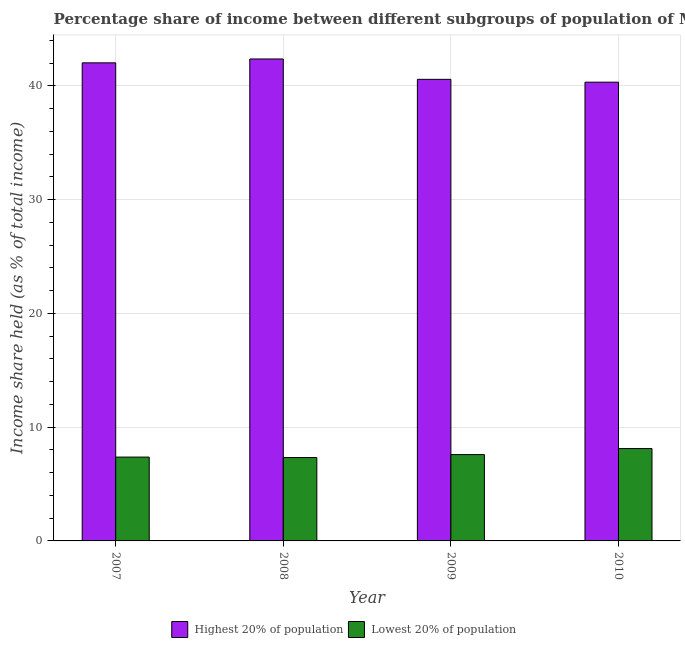How many bars are there on the 4th tick from the right?
Make the answer very short. 2. What is the label of the 2nd group of bars from the left?
Your answer should be compact. 2008. What is the income share held by lowest 20% of the population in 2009?
Keep it short and to the point. 7.59. Across all years, what is the maximum income share held by highest 20% of the population?
Offer a terse response. 42.37. Across all years, what is the minimum income share held by highest 20% of the population?
Your response must be concise. 40.33. In which year was the income share held by highest 20% of the population maximum?
Provide a short and direct response. 2008. What is the total income share held by lowest 20% of the population in the graph?
Offer a very short reply. 30.41. What is the difference between the income share held by lowest 20% of the population in 2007 and that in 2008?
Provide a short and direct response. 0.04. What is the difference between the income share held by lowest 20% of the population in 2009 and the income share held by highest 20% of the population in 2010?
Keep it short and to the point. -0.53. What is the average income share held by highest 20% of the population per year?
Your response must be concise. 41.33. In how many years, is the income share held by highest 20% of the population greater than 16 %?
Your answer should be compact. 4. What is the ratio of the income share held by highest 20% of the population in 2008 to that in 2009?
Ensure brevity in your answer.  1.04. Is the income share held by lowest 20% of the population in 2008 less than that in 2010?
Make the answer very short. Yes. Is the difference between the income share held by lowest 20% of the population in 2008 and 2010 greater than the difference between the income share held by highest 20% of the population in 2008 and 2010?
Ensure brevity in your answer.  No. What is the difference between the highest and the second highest income share held by highest 20% of the population?
Your answer should be very brief. 0.34. What is the difference between the highest and the lowest income share held by lowest 20% of the population?
Ensure brevity in your answer.  0.79. What does the 1st bar from the left in 2010 represents?
Make the answer very short. Highest 20% of population. What does the 1st bar from the right in 2009 represents?
Provide a short and direct response. Lowest 20% of population. How many bars are there?
Ensure brevity in your answer.  8. Are all the bars in the graph horizontal?
Provide a short and direct response. No. How many years are there in the graph?
Ensure brevity in your answer.  4. What is the difference between two consecutive major ticks on the Y-axis?
Give a very brief answer. 10. Are the values on the major ticks of Y-axis written in scientific E-notation?
Make the answer very short. No. Does the graph contain any zero values?
Provide a short and direct response. No. Does the graph contain grids?
Make the answer very short. Yes. Where does the legend appear in the graph?
Keep it short and to the point. Bottom center. How are the legend labels stacked?
Keep it short and to the point. Horizontal. What is the title of the graph?
Provide a succinct answer. Percentage share of income between different subgroups of population of Moldova. What is the label or title of the X-axis?
Ensure brevity in your answer.  Year. What is the label or title of the Y-axis?
Provide a short and direct response. Income share held (as % of total income). What is the Income share held (as % of total income) of Highest 20% of population in 2007?
Provide a succinct answer. 42.03. What is the Income share held (as % of total income) of Lowest 20% of population in 2007?
Provide a short and direct response. 7.37. What is the Income share held (as % of total income) in Highest 20% of population in 2008?
Make the answer very short. 42.37. What is the Income share held (as % of total income) in Lowest 20% of population in 2008?
Offer a very short reply. 7.33. What is the Income share held (as % of total income) of Highest 20% of population in 2009?
Offer a terse response. 40.58. What is the Income share held (as % of total income) of Lowest 20% of population in 2009?
Offer a terse response. 7.59. What is the Income share held (as % of total income) of Highest 20% of population in 2010?
Ensure brevity in your answer.  40.33. What is the Income share held (as % of total income) in Lowest 20% of population in 2010?
Make the answer very short. 8.12. Across all years, what is the maximum Income share held (as % of total income) of Highest 20% of population?
Provide a short and direct response. 42.37. Across all years, what is the maximum Income share held (as % of total income) of Lowest 20% of population?
Provide a succinct answer. 8.12. Across all years, what is the minimum Income share held (as % of total income) of Highest 20% of population?
Provide a short and direct response. 40.33. Across all years, what is the minimum Income share held (as % of total income) in Lowest 20% of population?
Keep it short and to the point. 7.33. What is the total Income share held (as % of total income) of Highest 20% of population in the graph?
Your answer should be compact. 165.31. What is the total Income share held (as % of total income) of Lowest 20% of population in the graph?
Offer a very short reply. 30.41. What is the difference between the Income share held (as % of total income) in Highest 20% of population in 2007 and that in 2008?
Give a very brief answer. -0.34. What is the difference between the Income share held (as % of total income) in Highest 20% of population in 2007 and that in 2009?
Offer a very short reply. 1.45. What is the difference between the Income share held (as % of total income) in Lowest 20% of population in 2007 and that in 2009?
Provide a short and direct response. -0.22. What is the difference between the Income share held (as % of total income) of Highest 20% of population in 2007 and that in 2010?
Provide a succinct answer. 1.7. What is the difference between the Income share held (as % of total income) in Lowest 20% of population in 2007 and that in 2010?
Your answer should be compact. -0.75. What is the difference between the Income share held (as % of total income) of Highest 20% of population in 2008 and that in 2009?
Ensure brevity in your answer.  1.79. What is the difference between the Income share held (as % of total income) of Lowest 20% of population in 2008 and that in 2009?
Make the answer very short. -0.26. What is the difference between the Income share held (as % of total income) of Highest 20% of population in 2008 and that in 2010?
Offer a terse response. 2.04. What is the difference between the Income share held (as % of total income) of Lowest 20% of population in 2008 and that in 2010?
Offer a very short reply. -0.79. What is the difference between the Income share held (as % of total income) of Lowest 20% of population in 2009 and that in 2010?
Your response must be concise. -0.53. What is the difference between the Income share held (as % of total income) of Highest 20% of population in 2007 and the Income share held (as % of total income) of Lowest 20% of population in 2008?
Provide a short and direct response. 34.7. What is the difference between the Income share held (as % of total income) of Highest 20% of population in 2007 and the Income share held (as % of total income) of Lowest 20% of population in 2009?
Make the answer very short. 34.44. What is the difference between the Income share held (as % of total income) of Highest 20% of population in 2007 and the Income share held (as % of total income) of Lowest 20% of population in 2010?
Ensure brevity in your answer.  33.91. What is the difference between the Income share held (as % of total income) in Highest 20% of population in 2008 and the Income share held (as % of total income) in Lowest 20% of population in 2009?
Offer a very short reply. 34.78. What is the difference between the Income share held (as % of total income) of Highest 20% of population in 2008 and the Income share held (as % of total income) of Lowest 20% of population in 2010?
Provide a short and direct response. 34.25. What is the difference between the Income share held (as % of total income) of Highest 20% of population in 2009 and the Income share held (as % of total income) of Lowest 20% of population in 2010?
Provide a succinct answer. 32.46. What is the average Income share held (as % of total income) of Highest 20% of population per year?
Your response must be concise. 41.33. What is the average Income share held (as % of total income) in Lowest 20% of population per year?
Make the answer very short. 7.6. In the year 2007, what is the difference between the Income share held (as % of total income) in Highest 20% of population and Income share held (as % of total income) in Lowest 20% of population?
Provide a short and direct response. 34.66. In the year 2008, what is the difference between the Income share held (as % of total income) in Highest 20% of population and Income share held (as % of total income) in Lowest 20% of population?
Provide a succinct answer. 35.04. In the year 2009, what is the difference between the Income share held (as % of total income) of Highest 20% of population and Income share held (as % of total income) of Lowest 20% of population?
Provide a short and direct response. 32.99. In the year 2010, what is the difference between the Income share held (as % of total income) of Highest 20% of population and Income share held (as % of total income) of Lowest 20% of population?
Provide a succinct answer. 32.21. What is the ratio of the Income share held (as % of total income) in Highest 20% of population in 2007 to that in 2008?
Offer a terse response. 0.99. What is the ratio of the Income share held (as % of total income) in Highest 20% of population in 2007 to that in 2009?
Provide a short and direct response. 1.04. What is the ratio of the Income share held (as % of total income) in Lowest 20% of population in 2007 to that in 2009?
Offer a terse response. 0.97. What is the ratio of the Income share held (as % of total income) of Highest 20% of population in 2007 to that in 2010?
Keep it short and to the point. 1.04. What is the ratio of the Income share held (as % of total income) of Lowest 20% of population in 2007 to that in 2010?
Make the answer very short. 0.91. What is the ratio of the Income share held (as % of total income) of Highest 20% of population in 2008 to that in 2009?
Give a very brief answer. 1.04. What is the ratio of the Income share held (as % of total income) of Lowest 20% of population in 2008 to that in 2009?
Make the answer very short. 0.97. What is the ratio of the Income share held (as % of total income) of Highest 20% of population in 2008 to that in 2010?
Your response must be concise. 1.05. What is the ratio of the Income share held (as % of total income) of Lowest 20% of population in 2008 to that in 2010?
Offer a very short reply. 0.9. What is the ratio of the Income share held (as % of total income) in Lowest 20% of population in 2009 to that in 2010?
Offer a very short reply. 0.93. What is the difference between the highest and the second highest Income share held (as % of total income) of Highest 20% of population?
Provide a succinct answer. 0.34. What is the difference between the highest and the second highest Income share held (as % of total income) of Lowest 20% of population?
Offer a very short reply. 0.53. What is the difference between the highest and the lowest Income share held (as % of total income) in Highest 20% of population?
Keep it short and to the point. 2.04. What is the difference between the highest and the lowest Income share held (as % of total income) of Lowest 20% of population?
Your answer should be very brief. 0.79. 